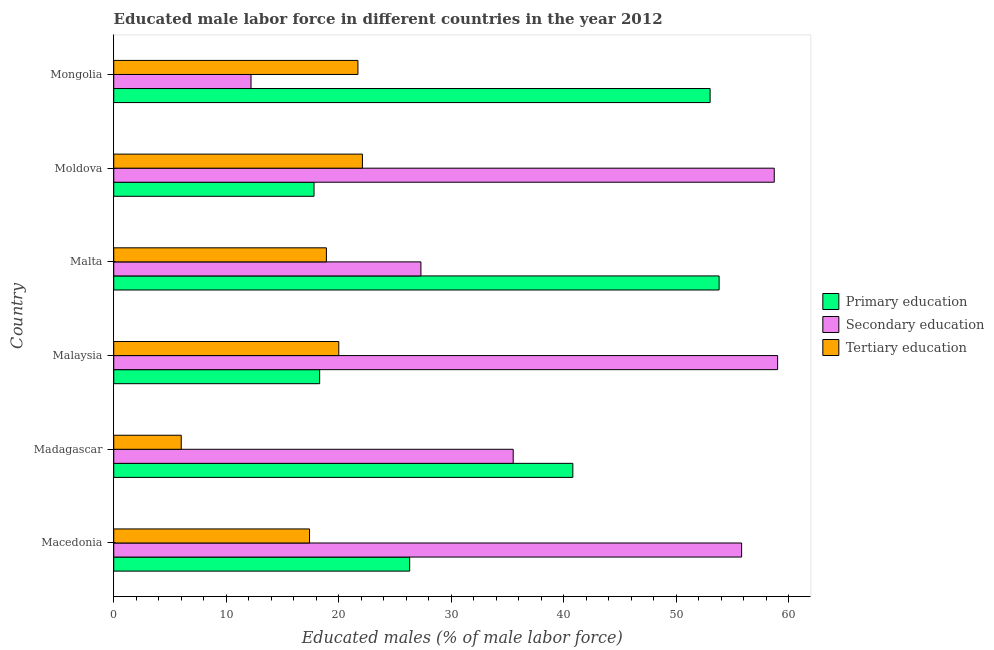How many different coloured bars are there?
Your answer should be compact. 3. How many groups of bars are there?
Offer a very short reply. 6. Are the number of bars on each tick of the Y-axis equal?
Provide a short and direct response. Yes. How many bars are there on the 6th tick from the top?
Provide a short and direct response. 3. What is the label of the 3rd group of bars from the top?
Provide a succinct answer. Malta. What is the percentage of male labor force who received primary education in Moldova?
Provide a short and direct response. 17.8. Across all countries, what is the minimum percentage of male labor force who received secondary education?
Ensure brevity in your answer.  12.2. In which country was the percentage of male labor force who received primary education maximum?
Keep it short and to the point. Malta. In which country was the percentage of male labor force who received secondary education minimum?
Provide a succinct answer. Mongolia. What is the total percentage of male labor force who received tertiary education in the graph?
Provide a succinct answer. 106.1. What is the difference between the percentage of male labor force who received secondary education in Malta and that in Mongolia?
Keep it short and to the point. 15.1. What is the difference between the percentage of male labor force who received primary education in Moldova and the percentage of male labor force who received tertiary education in Macedonia?
Offer a terse response. 0.4. What is the average percentage of male labor force who received primary education per country?
Your answer should be very brief. 35. What is the difference between the percentage of male labor force who received secondary education and percentage of male labor force who received primary education in Macedonia?
Ensure brevity in your answer.  29.5. What is the ratio of the percentage of male labor force who received primary education in Macedonia to that in Malta?
Keep it short and to the point. 0.49. Is the percentage of male labor force who received primary education in Macedonia less than that in Malaysia?
Your answer should be compact. No. What is the difference between the highest and the lowest percentage of male labor force who received tertiary education?
Your answer should be very brief. 16.1. Is the sum of the percentage of male labor force who received secondary education in Madagascar and Malta greater than the maximum percentage of male labor force who received tertiary education across all countries?
Make the answer very short. Yes. What does the 2nd bar from the top in Madagascar represents?
Offer a very short reply. Secondary education. What does the 2nd bar from the bottom in Malaysia represents?
Ensure brevity in your answer.  Secondary education. Is it the case that in every country, the sum of the percentage of male labor force who received primary education and percentage of male labor force who received secondary education is greater than the percentage of male labor force who received tertiary education?
Offer a terse response. Yes. How many bars are there?
Your answer should be compact. 18. Are the values on the major ticks of X-axis written in scientific E-notation?
Your answer should be compact. No. Does the graph contain grids?
Ensure brevity in your answer.  No. How many legend labels are there?
Make the answer very short. 3. What is the title of the graph?
Your answer should be compact. Educated male labor force in different countries in the year 2012. Does "Ireland" appear as one of the legend labels in the graph?
Your answer should be compact. No. What is the label or title of the X-axis?
Make the answer very short. Educated males (% of male labor force). What is the Educated males (% of male labor force) in Primary education in Macedonia?
Provide a succinct answer. 26.3. What is the Educated males (% of male labor force) in Secondary education in Macedonia?
Provide a short and direct response. 55.8. What is the Educated males (% of male labor force) of Tertiary education in Macedonia?
Your answer should be very brief. 17.4. What is the Educated males (% of male labor force) of Primary education in Madagascar?
Your answer should be compact. 40.8. What is the Educated males (% of male labor force) of Secondary education in Madagascar?
Your answer should be compact. 35.5. What is the Educated males (% of male labor force) in Tertiary education in Madagascar?
Keep it short and to the point. 6. What is the Educated males (% of male labor force) of Primary education in Malaysia?
Your answer should be very brief. 18.3. What is the Educated males (% of male labor force) of Secondary education in Malaysia?
Your answer should be very brief. 59. What is the Educated males (% of male labor force) of Primary education in Malta?
Your answer should be compact. 53.8. What is the Educated males (% of male labor force) of Secondary education in Malta?
Offer a terse response. 27.3. What is the Educated males (% of male labor force) of Tertiary education in Malta?
Provide a short and direct response. 18.9. What is the Educated males (% of male labor force) in Primary education in Moldova?
Offer a terse response. 17.8. What is the Educated males (% of male labor force) in Secondary education in Moldova?
Make the answer very short. 58.7. What is the Educated males (% of male labor force) in Tertiary education in Moldova?
Make the answer very short. 22.1. What is the Educated males (% of male labor force) of Primary education in Mongolia?
Offer a very short reply. 53. What is the Educated males (% of male labor force) of Secondary education in Mongolia?
Your answer should be very brief. 12.2. What is the Educated males (% of male labor force) in Tertiary education in Mongolia?
Your answer should be very brief. 21.7. Across all countries, what is the maximum Educated males (% of male labor force) of Primary education?
Offer a very short reply. 53.8. Across all countries, what is the maximum Educated males (% of male labor force) in Secondary education?
Make the answer very short. 59. Across all countries, what is the maximum Educated males (% of male labor force) of Tertiary education?
Offer a very short reply. 22.1. Across all countries, what is the minimum Educated males (% of male labor force) in Primary education?
Your answer should be very brief. 17.8. Across all countries, what is the minimum Educated males (% of male labor force) in Secondary education?
Your answer should be very brief. 12.2. Across all countries, what is the minimum Educated males (% of male labor force) in Tertiary education?
Make the answer very short. 6. What is the total Educated males (% of male labor force) of Primary education in the graph?
Make the answer very short. 210. What is the total Educated males (% of male labor force) in Secondary education in the graph?
Offer a very short reply. 248.5. What is the total Educated males (% of male labor force) in Tertiary education in the graph?
Provide a succinct answer. 106.1. What is the difference between the Educated males (% of male labor force) of Primary education in Macedonia and that in Madagascar?
Offer a very short reply. -14.5. What is the difference between the Educated males (% of male labor force) in Secondary education in Macedonia and that in Madagascar?
Provide a short and direct response. 20.3. What is the difference between the Educated males (% of male labor force) in Tertiary education in Macedonia and that in Madagascar?
Ensure brevity in your answer.  11.4. What is the difference between the Educated males (% of male labor force) of Primary education in Macedonia and that in Malta?
Your answer should be compact. -27.5. What is the difference between the Educated males (% of male labor force) in Secondary education in Macedonia and that in Moldova?
Provide a succinct answer. -2.9. What is the difference between the Educated males (% of male labor force) in Primary education in Macedonia and that in Mongolia?
Offer a terse response. -26.7. What is the difference between the Educated males (% of male labor force) of Secondary education in Macedonia and that in Mongolia?
Give a very brief answer. 43.6. What is the difference between the Educated males (% of male labor force) in Secondary education in Madagascar and that in Malaysia?
Your answer should be compact. -23.5. What is the difference between the Educated males (% of male labor force) of Primary education in Madagascar and that in Malta?
Offer a very short reply. -13. What is the difference between the Educated males (% of male labor force) of Secondary education in Madagascar and that in Malta?
Your answer should be compact. 8.2. What is the difference between the Educated males (% of male labor force) in Secondary education in Madagascar and that in Moldova?
Give a very brief answer. -23.2. What is the difference between the Educated males (% of male labor force) in Tertiary education in Madagascar and that in Moldova?
Make the answer very short. -16.1. What is the difference between the Educated males (% of male labor force) in Secondary education in Madagascar and that in Mongolia?
Offer a very short reply. 23.3. What is the difference between the Educated males (% of male labor force) of Tertiary education in Madagascar and that in Mongolia?
Your answer should be very brief. -15.7. What is the difference between the Educated males (% of male labor force) in Primary education in Malaysia and that in Malta?
Keep it short and to the point. -35.5. What is the difference between the Educated males (% of male labor force) of Secondary education in Malaysia and that in Malta?
Your answer should be compact. 31.7. What is the difference between the Educated males (% of male labor force) in Primary education in Malaysia and that in Moldova?
Offer a very short reply. 0.5. What is the difference between the Educated males (% of male labor force) in Secondary education in Malaysia and that in Moldova?
Offer a terse response. 0.3. What is the difference between the Educated males (% of male labor force) of Tertiary education in Malaysia and that in Moldova?
Provide a short and direct response. -2.1. What is the difference between the Educated males (% of male labor force) of Primary education in Malaysia and that in Mongolia?
Your response must be concise. -34.7. What is the difference between the Educated males (% of male labor force) of Secondary education in Malaysia and that in Mongolia?
Provide a succinct answer. 46.8. What is the difference between the Educated males (% of male labor force) in Secondary education in Malta and that in Moldova?
Offer a terse response. -31.4. What is the difference between the Educated males (% of male labor force) of Secondary education in Malta and that in Mongolia?
Keep it short and to the point. 15.1. What is the difference between the Educated males (% of male labor force) of Tertiary education in Malta and that in Mongolia?
Provide a short and direct response. -2.8. What is the difference between the Educated males (% of male labor force) in Primary education in Moldova and that in Mongolia?
Give a very brief answer. -35.2. What is the difference between the Educated males (% of male labor force) in Secondary education in Moldova and that in Mongolia?
Your answer should be very brief. 46.5. What is the difference between the Educated males (% of male labor force) of Tertiary education in Moldova and that in Mongolia?
Offer a very short reply. 0.4. What is the difference between the Educated males (% of male labor force) in Primary education in Macedonia and the Educated males (% of male labor force) in Secondary education in Madagascar?
Ensure brevity in your answer.  -9.2. What is the difference between the Educated males (% of male labor force) of Primary education in Macedonia and the Educated males (% of male labor force) of Tertiary education in Madagascar?
Provide a succinct answer. 20.3. What is the difference between the Educated males (% of male labor force) in Secondary education in Macedonia and the Educated males (% of male labor force) in Tertiary education in Madagascar?
Your answer should be very brief. 49.8. What is the difference between the Educated males (% of male labor force) in Primary education in Macedonia and the Educated males (% of male labor force) in Secondary education in Malaysia?
Give a very brief answer. -32.7. What is the difference between the Educated males (% of male labor force) of Primary education in Macedonia and the Educated males (% of male labor force) of Tertiary education in Malaysia?
Provide a short and direct response. 6.3. What is the difference between the Educated males (% of male labor force) of Secondary education in Macedonia and the Educated males (% of male labor force) of Tertiary education in Malaysia?
Your response must be concise. 35.8. What is the difference between the Educated males (% of male labor force) of Primary education in Macedonia and the Educated males (% of male labor force) of Tertiary education in Malta?
Your answer should be very brief. 7.4. What is the difference between the Educated males (% of male labor force) of Secondary education in Macedonia and the Educated males (% of male labor force) of Tertiary education in Malta?
Make the answer very short. 36.9. What is the difference between the Educated males (% of male labor force) of Primary education in Macedonia and the Educated males (% of male labor force) of Secondary education in Moldova?
Provide a short and direct response. -32.4. What is the difference between the Educated males (% of male labor force) of Primary education in Macedonia and the Educated males (% of male labor force) of Tertiary education in Moldova?
Offer a terse response. 4.2. What is the difference between the Educated males (% of male labor force) of Secondary education in Macedonia and the Educated males (% of male labor force) of Tertiary education in Moldova?
Your answer should be compact. 33.7. What is the difference between the Educated males (% of male labor force) of Primary education in Macedonia and the Educated males (% of male labor force) of Tertiary education in Mongolia?
Provide a short and direct response. 4.6. What is the difference between the Educated males (% of male labor force) in Secondary education in Macedonia and the Educated males (% of male labor force) in Tertiary education in Mongolia?
Provide a succinct answer. 34.1. What is the difference between the Educated males (% of male labor force) of Primary education in Madagascar and the Educated males (% of male labor force) of Secondary education in Malaysia?
Offer a very short reply. -18.2. What is the difference between the Educated males (% of male labor force) in Primary education in Madagascar and the Educated males (% of male labor force) in Tertiary education in Malaysia?
Your response must be concise. 20.8. What is the difference between the Educated males (% of male labor force) in Secondary education in Madagascar and the Educated males (% of male labor force) in Tertiary education in Malaysia?
Your response must be concise. 15.5. What is the difference between the Educated males (% of male labor force) in Primary education in Madagascar and the Educated males (% of male labor force) in Tertiary education in Malta?
Offer a very short reply. 21.9. What is the difference between the Educated males (% of male labor force) of Primary education in Madagascar and the Educated males (% of male labor force) of Secondary education in Moldova?
Provide a succinct answer. -17.9. What is the difference between the Educated males (% of male labor force) in Primary education in Madagascar and the Educated males (% of male labor force) in Tertiary education in Moldova?
Ensure brevity in your answer.  18.7. What is the difference between the Educated males (% of male labor force) in Primary education in Madagascar and the Educated males (% of male labor force) in Secondary education in Mongolia?
Ensure brevity in your answer.  28.6. What is the difference between the Educated males (% of male labor force) of Secondary education in Malaysia and the Educated males (% of male labor force) of Tertiary education in Malta?
Offer a terse response. 40.1. What is the difference between the Educated males (% of male labor force) of Primary education in Malaysia and the Educated males (% of male labor force) of Secondary education in Moldova?
Your answer should be very brief. -40.4. What is the difference between the Educated males (% of male labor force) of Primary education in Malaysia and the Educated males (% of male labor force) of Tertiary education in Moldova?
Offer a very short reply. -3.8. What is the difference between the Educated males (% of male labor force) of Secondary education in Malaysia and the Educated males (% of male labor force) of Tertiary education in Moldova?
Your answer should be compact. 36.9. What is the difference between the Educated males (% of male labor force) in Primary education in Malaysia and the Educated males (% of male labor force) in Tertiary education in Mongolia?
Give a very brief answer. -3.4. What is the difference between the Educated males (% of male labor force) of Secondary education in Malaysia and the Educated males (% of male labor force) of Tertiary education in Mongolia?
Your answer should be very brief. 37.3. What is the difference between the Educated males (% of male labor force) in Primary education in Malta and the Educated males (% of male labor force) in Tertiary education in Moldova?
Provide a short and direct response. 31.7. What is the difference between the Educated males (% of male labor force) of Primary education in Malta and the Educated males (% of male labor force) of Secondary education in Mongolia?
Your response must be concise. 41.6. What is the difference between the Educated males (% of male labor force) of Primary education in Malta and the Educated males (% of male labor force) of Tertiary education in Mongolia?
Your answer should be compact. 32.1. What is the difference between the Educated males (% of male labor force) of Primary education in Moldova and the Educated males (% of male labor force) of Tertiary education in Mongolia?
Your response must be concise. -3.9. What is the average Educated males (% of male labor force) in Secondary education per country?
Make the answer very short. 41.42. What is the average Educated males (% of male labor force) of Tertiary education per country?
Your response must be concise. 17.68. What is the difference between the Educated males (% of male labor force) of Primary education and Educated males (% of male labor force) of Secondary education in Macedonia?
Keep it short and to the point. -29.5. What is the difference between the Educated males (% of male labor force) of Primary education and Educated males (% of male labor force) of Tertiary education in Macedonia?
Provide a succinct answer. 8.9. What is the difference between the Educated males (% of male labor force) in Secondary education and Educated males (% of male labor force) in Tertiary education in Macedonia?
Keep it short and to the point. 38.4. What is the difference between the Educated males (% of male labor force) of Primary education and Educated males (% of male labor force) of Secondary education in Madagascar?
Your response must be concise. 5.3. What is the difference between the Educated males (% of male labor force) in Primary education and Educated males (% of male labor force) in Tertiary education in Madagascar?
Offer a terse response. 34.8. What is the difference between the Educated males (% of male labor force) of Secondary education and Educated males (% of male labor force) of Tertiary education in Madagascar?
Your response must be concise. 29.5. What is the difference between the Educated males (% of male labor force) in Primary education and Educated males (% of male labor force) in Secondary education in Malaysia?
Your response must be concise. -40.7. What is the difference between the Educated males (% of male labor force) of Secondary education and Educated males (% of male labor force) of Tertiary education in Malaysia?
Your answer should be very brief. 39. What is the difference between the Educated males (% of male labor force) in Primary education and Educated males (% of male labor force) in Tertiary education in Malta?
Give a very brief answer. 34.9. What is the difference between the Educated males (% of male labor force) in Primary education and Educated males (% of male labor force) in Secondary education in Moldova?
Make the answer very short. -40.9. What is the difference between the Educated males (% of male labor force) of Primary education and Educated males (% of male labor force) of Tertiary education in Moldova?
Offer a terse response. -4.3. What is the difference between the Educated males (% of male labor force) of Secondary education and Educated males (% of male labor force) of Tertiary education in Moldova?
Provide a succinct answer. 36.6. What is the difference between the Educated males (% of male labor force) of Primary education and Educated males (% of male labor force) of Secondary education in Mongolia?
Keep it short and to the point. 40.8. What is the difference between the Educated males (% of male labor force) in Primary education and Educated males (% of male labor force) in Tertiary education in Mongolia?
Ensure brevity in your answer.  31.3. What is the difference between the Educated males (% of male labor force) in Secondary education and Educated males (% of male labor force) in Tertiary education in Mongolia?
Offer a very short reply. -9.5. What is the ratio of the Educated males (% of male labor force) in Primary education in Macedonia to that in Madagascar?
Your response must be concise. 0.64. What is the ratio of the Educated males (% of male labor force) of Secondary education in Macedonia to that in Madagascar?
Offer a very short reply. 1.57. What is the ratio of the Educated males (% of male labor force) in Primary education in Macedonia to that in Malaysia?
Give a very brief answer. 1.44. What is the ratio of the Educated males (% of male labor force) of Secondary education in Macedonia to that in Malaysia?
Your response must be concise. 0.95. What is the ratio of the Educated males (% of male labor force) in Tertiary education in Macedonia to that in Malaysia?
Keep it short and to the point. 0.87. What is the ratio of the Educated males (% of male labor force) of Primary education in Macedonia to that in Malta?
Ensure brevity in your answer.  0.49. What is the ratio of the Educated males (% of male labor force) of Secondary education in Macedonia to that in Malta?
Offer a terse response. 2.04. What is the ratio of the Educated males (% of male labor force) of Tertiary education in Macedonia to that in Malta?
Give a very brief answer. 0.92. What is the ratio of the Educated males (% of male labor force) of Primary education in Macedonia to that in Moldova?
Give a very brief answer. 1.48. What is the ratio of the Educated males (% of male labor force) in Secondary education in Macedonia to that in Moldova?
Keep it short and to the point. 0.95. What is the ratio of the Educated males (% of male labor force) in Tertiary education in Macedonia to that in Moldova?
Make the answer very short. 0.79. What is the ratio of the Educated males (% of male labor force) of Primary education in Macedonia to that in Mongolia?
Your response must be concise. 0.5. What is the ratio of the Educated males (% of male labor force) in Secondary education in Macedonia to that in Mongolia?
Your response must be concise. 4.57. What is the ratio of the Educated males (% of male labor force) of Tertiary education in Macedonia to that in Mongolia?
Your response must be concise. 0.8. What is the ratio of the Educated males (% of male labor force) of Primary education in Madagascar to that in Malaysia?
Your response must be concise. 2.23. What is the ratio of the Educated males (% of male labor force) of Secondary education in Madagascar to that in Malaysia?
Your answer should be very brief. 0.6. What is the ratio of the Educated males (% of male labor force) of Tertiary education in Madagascar to that in Malaysia?
Offer a very short reply. 0.3. What is the ratio of the Educated males (% of male labor force) in Primary education in Madagascar to that in Malta?
Offer a very short reply. 0.76. What is the ratio of the Educated males (% of male labor force) in Secondary education in Madagascar to that in Malta?
Offer a very short reply. 1.3. What is the ratio of the Educated males (% of male labor force) in Tertiary education in Madagascar to that in Malta?
Offer a terse response. 0.32. What is the ratio of the Educated males (% of male labor force) in Primary education in Madagascar to that in Moldova?
Keep it short and to the point. 2.29. What is the ratio of the Educated males (% of male labor force) of Secondary education in Madagascar to that in Moldova?
Provide a succinct answer. 0.6. What is the ratio of the Educated males (% of male labor force) in Tertiary education in Madagascar to that in Moldova?
Make the answer very short. 0.27. What is the ratio of the Educated males (% of male labor force) of Primary education in Madagascar to that in Mongolia?
Your answer should be compact. 0.77. What is the ratio of the Educated males (% of male labor force) in Secondary education in Madagascar to that in Mongolia?
Offer a very short reply. 2.91. What is the ratio of the Educated males (% of male labor force) in Tertiary education in Madagascar to that in Mongolia?
Keep it short and to the point. 0.28. What is the ratio of the Educated males (% of male labor force) of Primary education in Malaysia to that in Malta?
Give a very brief answer. 0.34. What is the ratio of the Educated males (% of male labor force) of Secondary education in Malaysia to that in Malta?
Make the answer very short. 2.16. What is the ratio of the Educated males (% of male labor force) in Tertiary education in Malaysia to that in Malta?
Provide a short and direct response. 1.06. What is the ratio of the Educated males (% of male labor force) in Primary education in Malaysia to that in Moldova?
Provide a succinct answer. 1.03. What is the ratio of the Educated males (% of male labor force) in Secondary education in Malaysia to that in Moldova?
Your answer should be very brief. 1.01. What is the ratio of the Educated males (% of male labor force) in Tertiary education in Malaysia to that in Moldova?
Your answer should be compact. 0.91. What is the ratio of the Educated males (% of male labor force) in Primary education in Malaysia to that in Mongolia?
Your response must be concise. 0.35. What is the ratio of the Educated males (% of male labor force) in Secondary education in Malaysia to that in Mongolia?
Your answer should be compact. 4.84. What is the ratio of the Educated males (% of male labor force) in Tertiary education in Malaysia to that in Mongolia?
Make the answer very short. 0.92. What is the ratio of the Educated males (% of male labor force) in Primary education in Malta to that in Moldova?
Give a very brief answer. 3.02. What is the ratio of the Educated males (% of male labor force) in Secondary education in Malta to that in Moldova?
Your response must be concise. 0.47. What is the ratio of the Educated males (% of male labor force) of Tertiary education in Malta to that in Moldova?
Your answer should be compact. 0.86. What is the ratio of the Educated males (% of male labor force) of Primary education in Malta to that in Mongolia?
Make the answer very short. 1.02. What is the ratio of the Educated males (% of male labor force) of Secondary education in Malta to that in Mongolia?
Offer a very short reply. 2.24. What is the ratio of the Educated males (% of male labor force) of Tertiary education in Malta to that in Mongolia?
Ensure brevity in your answer.  0.87. What is the ratio of the Educated males (% of male labor force) of Primary education in Moldova to that in Mongolia?
Keep it short and to the point. 0.34. What is the ratio of the Educated males (% of male labor force) of Secondary education in Moldova to that in Mongolia?
Give a very brief answer. 4.81. What is the ratio of the Educated males (% of male labor force) in Tertiary education in Moldova to that in Mongolia?
Make the answer very short. 1.02. What is the difference between the highest and the second highest Educated males (% of male labor force) of Secondary education?
Give a very brief answer. 0.3. What is the difference between the highest and the second highest Educated males (% of male labor force) of Tertiary education?
Your answer should be very brief. 0.4. What is the difference between the highest and the lowest Educated males (% of male labor force) of Secondary education?
Provide a short and direct response. 46.8. 